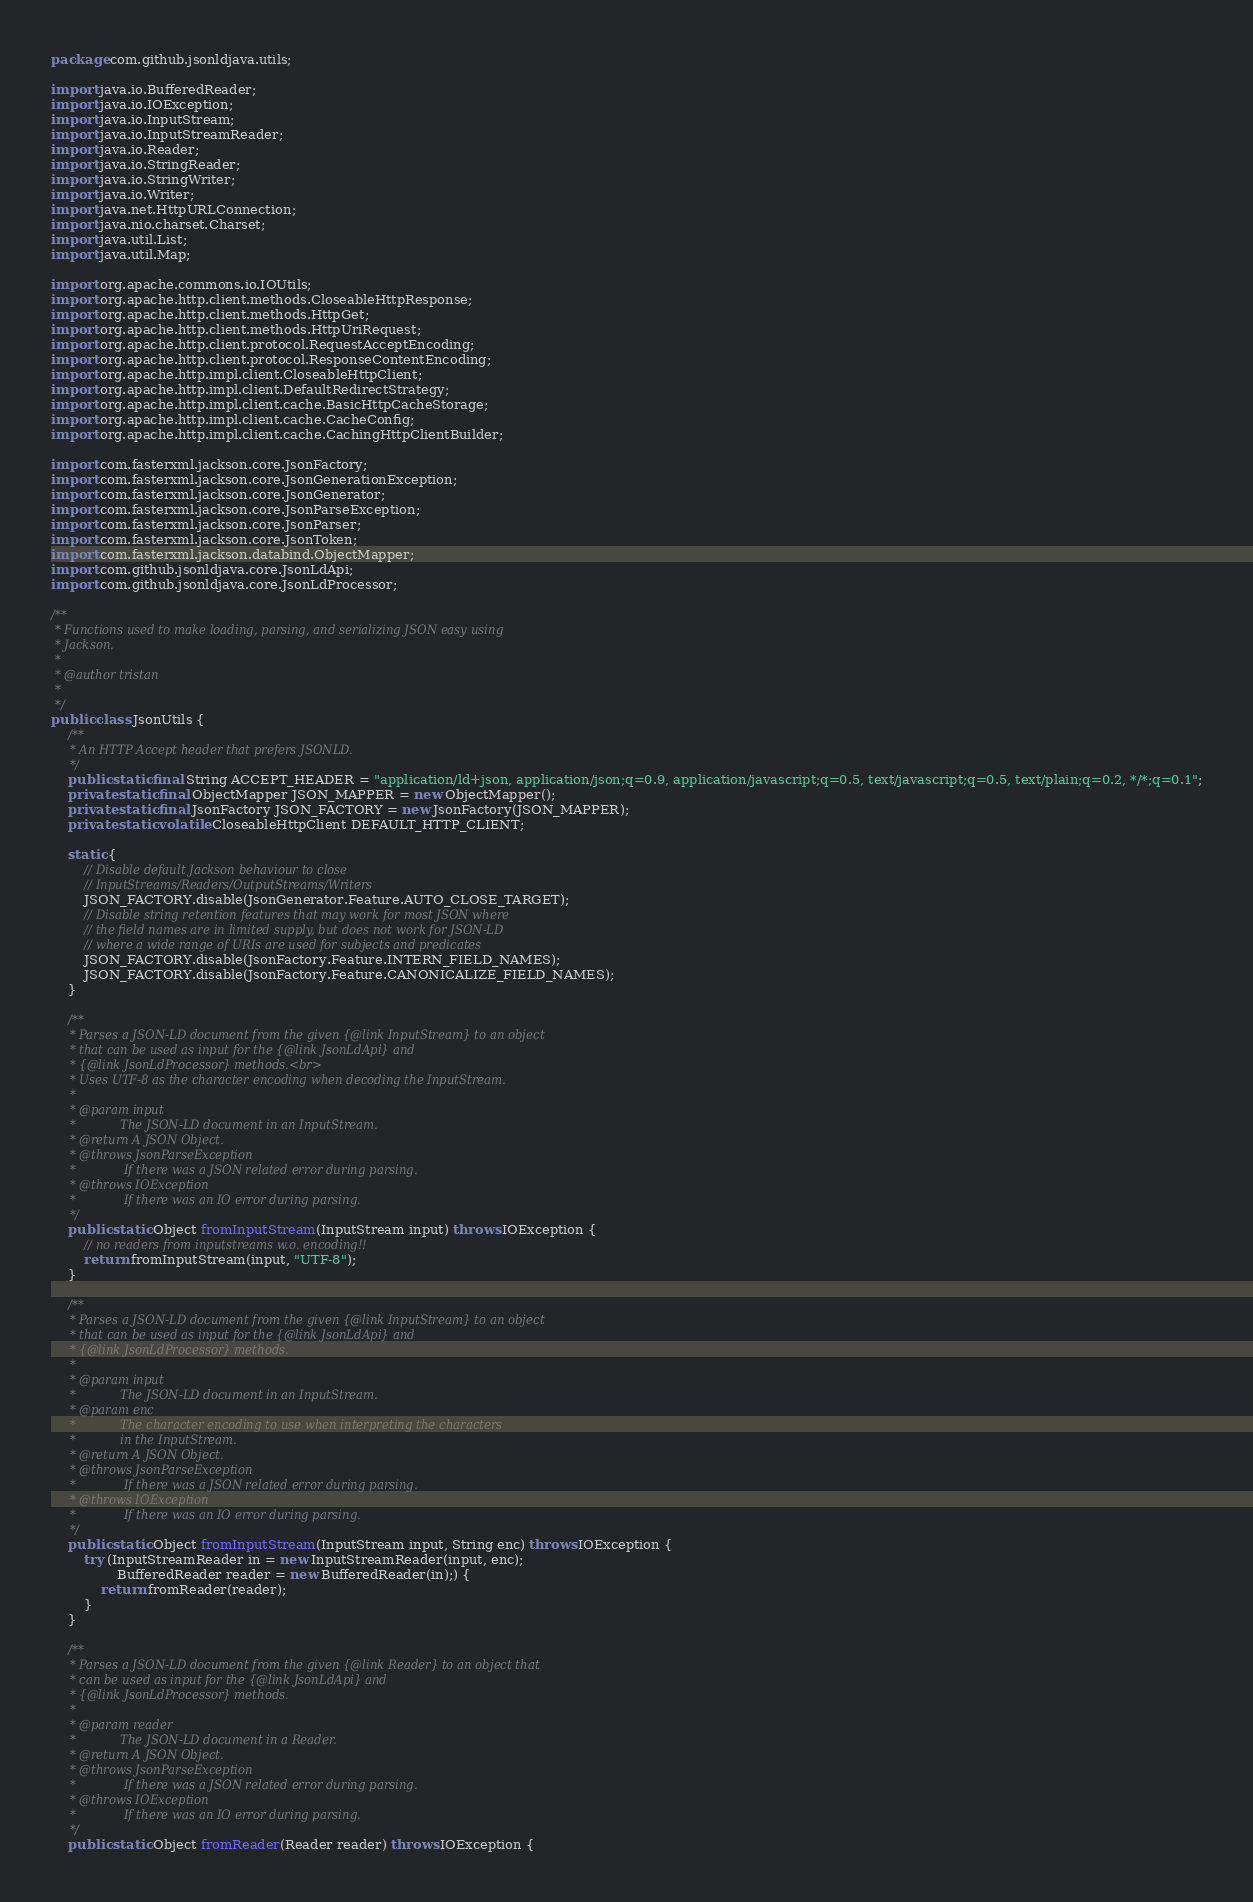Convert code to text. <code><loc_0><loc_0><loc_500><loc_500><_Java_>package com.github.jsonldjava.utils;

import java.io.BufferedReader;
import java.io.IOException;
import java.io.InputStream;
import java.io.InputStreamReader;
import java.io.Reader;
import java.io.StringReader;
import java.io.StringWriter;
import java.io.Writer;
import java.net.HttpURLConnection;
import java.nio.charset.Charset;
import java.util.List;
import java.util.Map;

import org.apache.commons.io.IOUtils;
import org.apache.http.client.methods.CloseableHttpResponse;
import org.apache.http.client.methods.HttpGet;
import org.apache.http.client.methods.HttpUriRequest;
import org.apache.http.client.protocol.RequestAcceptEncoding;
import org.apache.http.client.protocol.ResponseContentEncoding;
import org.apache.http.impl.client.CloseableHttpClient;
import org.apache.http.impl.client.DefaultRedirectStrategy;
import org.apache.http.impl.client.cache.BasicHttpCacheStorage;
import org.apache.http.impl.client.cache.CacheConfig;
import org.apache.http.impl.client.cache.CachingHttpClientBuilder;

import com.fasterxml.jackson.core.JsonFactory;
import com.fasterxml.jackson.core.JsonGenerationException;
import com.fasterxml.jackson.core.JsonGenerator;
import com.fasterxml.jackson.core.JsonParseException;
import com.fasterxml.jackson.core.JsonParser;
import com.fasterxml.jackson.core.JsonToken;
import com.fasterxml.jackson.databind.ObjectMapper;
import com.github.jsonldjava.core.JsonLdApi;
import com.github.jsonldjava.core.JsonLdProcessor;

/**
 * Functions used to make loading, parsing, and serializing JSON easy using
 * Jackson.
 *
 * @author tristan
 *
 */
public class JsonUtils {
    /**
     * An HTTP Accept header that prefers JSONLD.
     */
    public static final String ACCEPT_HEADER = "application/ld+json, application/json;q=0.9, application/javascript;q=0.5, text/javascript;q=0.5, text/plain;q=0.2, */*;q=0.1";
    private static final ObjectMapper JSON_MAPPER = new ObjectMapper();
    private static final JsonFactory JSON_FACTORY = new JsonFactory(JSON_MAPPER);
    private static volatile CloseableHttpClient DEFAULT_HTTP_CLIENT;

    static {
        // Disable default Jackson behaviour to close
        // InputStreams/Readers/OutputStreams/Writers
        JSON_FACTORY.disable(JsonGenerator.Feature.AUTO_CLOSE_TARGET);
        // Disable string retention features that may work for most JSON where
        // the field names are in limited supply, but does not work for JSON-LD
        // where a wide range of URIs are used for subjects and predicates
        JSON_FACTORY.disable(JsonFactory.Feature.INTERN_FIELD_NAMES);
        JSON_FACTORY.disable(JsonFactory.Feature.CANONICALIZE_FIELD_NAMES);
    }

    /**
     * Parses a JSON-LD document from the given {@link InputStream} to an object
     * that can be used as input for the {@link JsonLdApi} and
     * {@link JsonLdProcessor} methods.<br>
     * Uses UTF-8 as the character encoding when decoding the InputStream.
     *
     * @param input
     *            The JSON-LD document in an InputStream.
     * @return A JSON Object.
     * @throws JsonParseException
     *             If there was a JSON related error during parsing.
     * @throws IOException
     *             If there was an IO error during parsing.
     */
    public static Object fromInputStream(InputStream input) throws IOException {
        // no readers from inputstreams w.o. encoding!!
        return fromInputStream(input, "UTF-8");
    }

    /**
     * Parses a JSON-LD document from the given {@link InputStream} to an object
     * that can be used as input for the {@link JsonLdApi} and
     * {@link JsonLdProcessor} methods.
     *
     * @param input
     *            The JSON-LD document in an InputStream.
     * @param enc
     *            The character encoding to use when interpreting the characters
     *            in the InputStream.
     * @return A JSON Object.
     * @throws JsonParseException
     *             If there was a JSON related error during parsing.
     * @throws IOException
     *             If there was an IO error during parsing.
     */
    public static Object fromInputStream(InputStream input, String enc) throws IOException {
        try (InputStreamReader in = new InputStreamReader(input, enc);
                BufferedReader reader = new BufferedReader(in);) {
            return fromReader(reader);
        }
    }

    /**
     * Parses a JSON-LD document from the given {@link Reader} to an object that
     * can be used as input for the {@link JsonLdApi} and
     * {@link JsonLdProcessor} methods.
     *
     * @param reader
     *            The JSON-LD document in a Reader.
     * @return A JSON Object.
     * @throws JsonParseException
     *             If there was a JSON related error during parsing.
     * @throws IOException
     *             If there was an IO error during parsing.
     */
    public static Object fromReader(Reader reader) throws IOException {</code> 